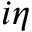Convert formula to latex. <formula><loc_0><loc_0><loc_500><loc_500>i \eta</formula> 